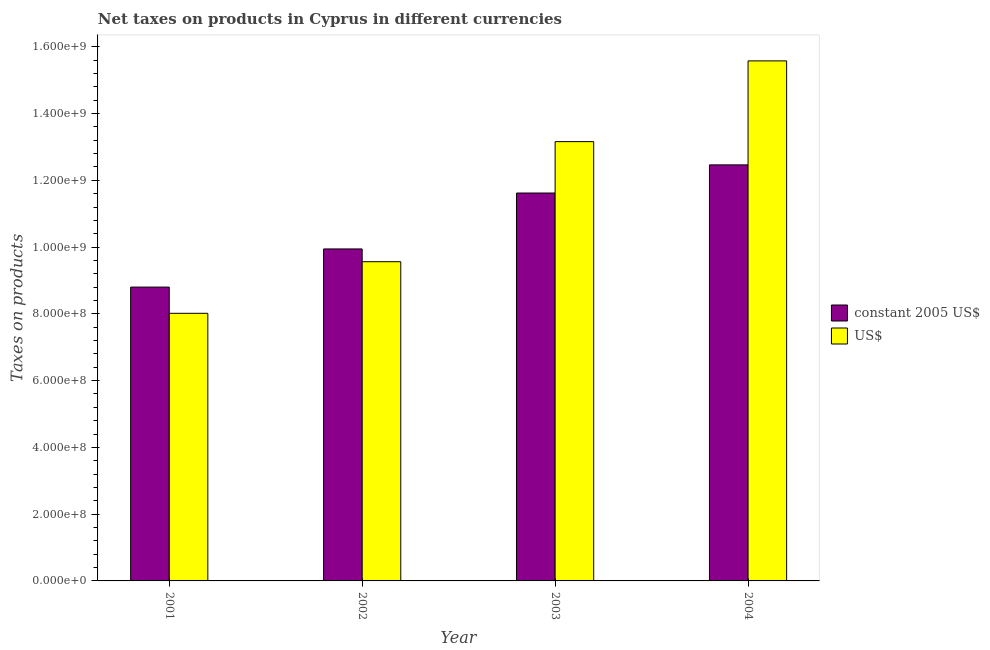How many groups of bars are there?
Keep it short and to the point. 4. How many bars are there on the 2nd tick from the right?
Make the answer very short. 2. What is the net taxes in constant 2005 us$ in 2004?
Your response must be concise. 1.25e+09. Across all years, what is the maximum net taxes in us$?
Offer a terse response. 1.56e+09. Across all years, what is the minimum net taxes in us$?
Your answer should be compact. 8.02e+08. In which year was the net taxes in constant 2005 us$ maximum?
Make the answer very short. 2004. What is the total net taxes in constant 2005 us$ in the graph?
Make the answer very short. 4.28e+09. What is the difference between the net taxes in constant 2005 us$ in 2001 and that in 2004?
Offer a terse response. -3.66e+08. What is the difference between the net taxes in constant 2005 us$ in 2003 and the net taxes in us$ in 2002?
Make the answer very short. 1.68e+08. What is the average net taxes in us$ per year?
Your response must be concise. 1.16e+09. What is the ratio of the net taxes in us$ in 2002 to that in 2003?
Offer a very short reply. 0.73. Is the difference between the net taxes in us$ in 2001 and 2004 greater than the difference between the net taxes in constant 2005 us$ in 2001 and 2004?
Your response must be concise. No. What is the difference between the highest and the second highest net taxes in constant 2005 us$?
Provide a succinct answer. 8.43e+07. What is the difference between the highest and the lowest net taxes in us$?
Offer a very short reply. 7.56e+08. Is the sum of the net taxes in constant 2005 us$ in 2001 and 2004 greater than the maximum net taxes in us$ across all years?
Your answer should be very brief. Yes. What does the 1st bar from the left in 2004 represents?
Give a very brief answer. Constant 2005 us$. What does the 2nd bar from the right in 2001 represents?
Provide a succinct answer. Constant 2005 us$. How many bars are there?
Your answer should be very brief. 8. How many years are there in the graph?
Offer a very short reply. 4. Are the values on the major ticks of Y-axis written in scientific E-notation?
Your answer should be compact. Yes. Does the graph contain any zero values?
Provide a short and direct response. No. How are the legend labels stacked?
Your response must be concise. Vertical. What is the title of the graph?
Provide a short and direct response. Net taxes on products in Cyprus in different currencies. What is the label or title of the Y-axis?
Make the answer very short. Taxes on products. What is the Taxes on products in constant 2005 US$ in 2001?
Provide a succinct answer. 8.80e+08. What is the Taxes on products of US$ in 2001?
Keep it short and to the point. 8.02e+08. What is the Taxes on products in constant 2005 US$ in 2002?
Offer a terse response. 9.95e+08. What is the Taxes on products in US$ in 2002?
Offer a terse response. 9.56e+08. What is the Taxes on products of constant 2005 US$ in 2003?
Give a very brief answer. 1.16e+09. What is the Taxes on products in US$ in 2003?
Offer a very short reply. 1.32e+09. What is the Taxes on products of constant 2005 US$ in 2004?
Make the answer very short. 1.25e+09. What is the Taxes on products in US$ in 2004?
Offer a very short reply. 1.56e+09. Across all years, what is the maximum Taxes on products of constant 2005 US$?
Your response must be concise. 1.25e+09. Across all years, what is the maximum Taxes on products in US$?
Make the answer very short. 1.56e+09. Across all years, what is the minimum Taxes on products in constant 2005 US$?
Offer a terse response. 8.80e+08. Across all years, what is the minimum Taxes on products of US$?
Your response must be concise. 8.02e+08. What is the total Taxes on products in constant 2005 US$ in the graph?
Ensure brevity in your answer.  4.28e+09. What is the total Taxes on products of US$ in the graph?
Keep it short and to the point. 4.63e+09. What is the difference between the Taxes on products in constant 2005 US$ in 2001 and that in 2002?
Provide a short and direct response. -1.14e+08. What is the difference between the Taxes on products in US$ in 2001 and that in 2002?
Your answer should be compact. -1.55e+08. What is the difference between the Taxes on products in constant 2005 US$ in 2001 and that in 2003?
Provide a succinct answer. -2.82e+08. What is the difference between the Taxes on products of US$ in 2001 and that in 2003?
Ensure brevity in your answer.  -5.14e+08. What is the difference between the Taxes on products of constant 2005 US$ in 2001 and that in 2004?
Your answer should be compact. -3.66e+08. What is the difference between the Taxes on products of US$ in 2001 and that in 2004?
Give a very brief answer. -7.56e+08. What is the difference between the Taxes on products in constant 2005 US$ in 2002 and that in 2003?
Give a very brief answer. -1.68e+08. What is the difference between the Taxes on products of US$ in 2002 and that in 2003?
Your answer should be very brief. -3.60e+08. What is the difference between the Taxes on products in constant 2005 US$ in 2002 and that in 2004?
Provide a succinct answer. -2.52e+08. What is the difference between the Taxes on products of US$ in 2002 and that in 2004?
Provide a short and direct response. -6.02e+08. What is the difference between the Taxes on products of constant 2005 US$ in 2003 and that in 2004?
Provide a succinct answer. -8.43e+07. What is the difference between the Taxes on products of US$ in 2003 and that in 2004?
Make the answer very short. -2.42e+08. What is the difference between the Taxes on products in constant 2005 US$ in 2001 and the Taxes on products in US$ in 2002?
Give a very brief answer. -7.60e+07. What is the difference between the Taxes on products of constant 2005 US$ in 2001 and the Taxes on products of US$ in 2003?
Ensure brevity in your answer.  -4.36e+08. What is the difference between the Taxes on products in constant 2005 US$ in 2001 and the Taxes on products in US$ in 2004?
Provide a succinct answer. -6.78e+08. What is the difference between the Taxes on products in constant 2005 US$ in 2002 and the Taxes on products in US$ in 2003?
Make the answer very short. -3.21e+08. What is the difference between the Taxes on products in constant 2005 US$ in 2002 and the Taxes on products in US$ in 2004?
Your answer should be very brief. -5.63e+08. What is the difference between the Taxes on products of constant 2005 US$ in 2003 and the Taxes on products of US$ in 2004?
Offer a terse response. -3.96e+08. What is the average Taxes on products of constant 2005 US$ per year?
Ensure brevity in your answer.  1.07e+09. What is the average Taxes on products of US$ per year?
Offer a very short reply. 1.16e+09. In the year 2001, what is the difference between the Taxes on products of constant 2005 US$ and Taxes on products of US$?
Provide a succinct answer. 7.86e+07. In the year 2002, what is the difference between the Taxes on products of constant 2005 US$ and Taxes on products of US$?
Keep it short and to the point. 3.83e+07. In the year 2003, what is the difference between the Taxes on products of constant 2005 US$ and Taxes on products of US$?
Make the answer very short. -1.54e+08. In the year 2004, what is the difference between the Taxes on products of constant 2005 US$ and Taxes on products of US$?
Keep it short and to the point. -3.12e+08. What is the ratio of the Taxes on products of constant 2005 US$ in 2001 to that in 2002?
Your response must be concise. 0.89. What is the ratio of the Taxes on products in US$ in 2001 to that in 2002?
Give a very brief answer. 0.84. What is the ratio of the Taxes on products of constant 2005 US$ in 2001 to that in 2003?
Your answer should be very brief. 0.76. What is the ratio of the Taxes on products in US$ in 2001 to that in 2003?
Your response must be concise. 0.61. What is the ratio of the Taxes on products of constant 2005 US$ in 2001 to that in 2004?
Offer a terse response. 0.71. What is the ratio of the Taxes on products in US$ in 2001 to that in 2004?
Offer a very short reply. 0.51. What is the ratio of the Taxes on products of constant 2005 US$ in 2002 to that in 2003?
Keep it short and to the point. 0.86. What is the ratio of the Taxes on products in US$ in 2002 to that in 2003?
Give a very brief answer. 0.73. What is the ratio of the Taxes on products of constant 2005 US$ in 2002 to that in 2004?
Keep it short and to the point. 0.8. What is the ratio of the Taxes on products in US$ in 2002 to that in 2004?
Give a very brief answer. 0.61. What is the ratio of the Taxes on products of constant 2005 US$ in 2003 to that in 2004?
Your answer should be very brief. 0.93. What is the ratio of the Taxes on products of US$ in 2003 to that in 2004?
Provide a succinct answer. 0.84. What is the difference between the highest and the second highest Taxes on products in constant 2005 US$?
Provide a short and direct response. 8.43e+07. What is the difference between the highest and the second highest Taxes on products in US$?
Your response must be concise. 2.42e+08. What is the difference between the highest and the lowest Taxes on products of constant 2005 US$?
Offer a terse response. 3.66e+08. What is the difference between the highest and the lowest Taxes on products of US$?
Provide a short and direct response. 7.56e+08. 